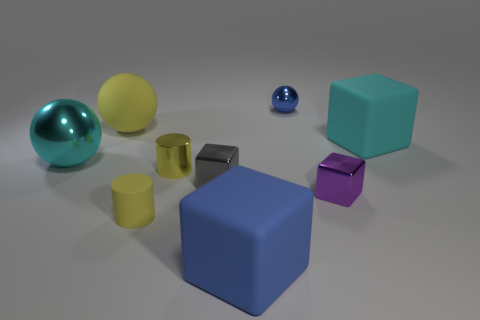Subtract all cubes. How many objects are left? 5 Add 1 small cylinders. How many small cylinders exist? 3 Subtract 0 gray spheres. How many objects are left? 9 Subtract all small yellow metallic things. Subtract all yellow matte spheres. How many objects are left? 7 Add 9 rubber cylinders. How many rubber cylinders are left? 10 